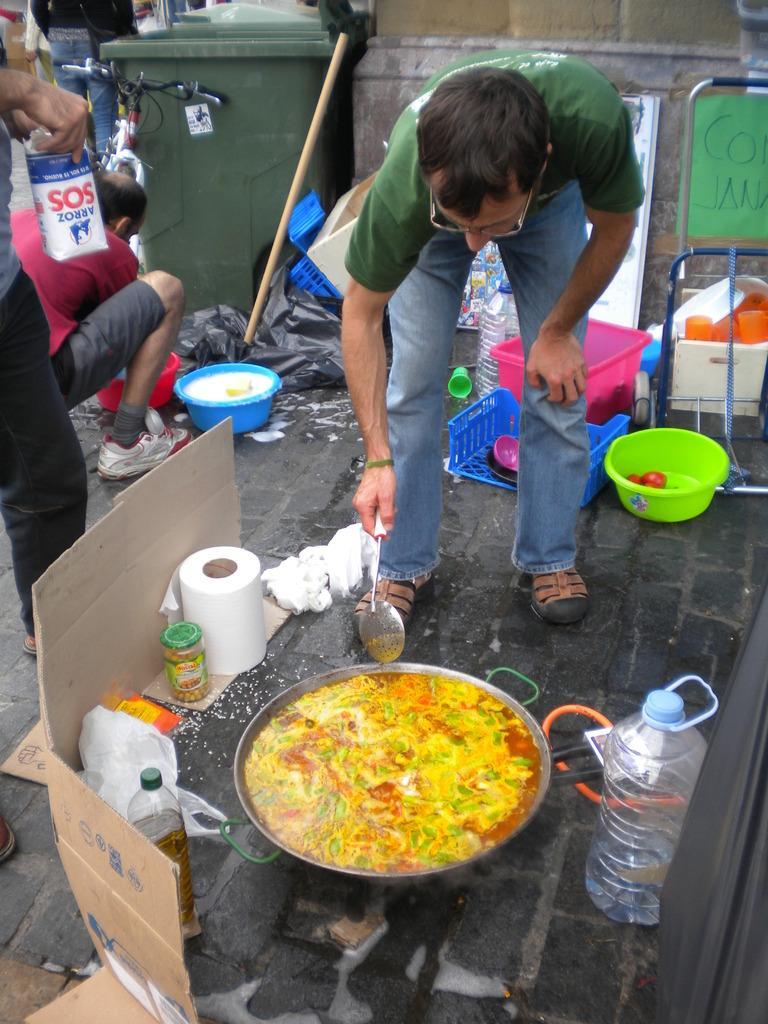Could you give a brief overview of what you see in this image? In the image there is a man cooking some food in a vessel, around the vessel there are groceries. Behind the man there are tubs, trash bin, cycle and other people. 